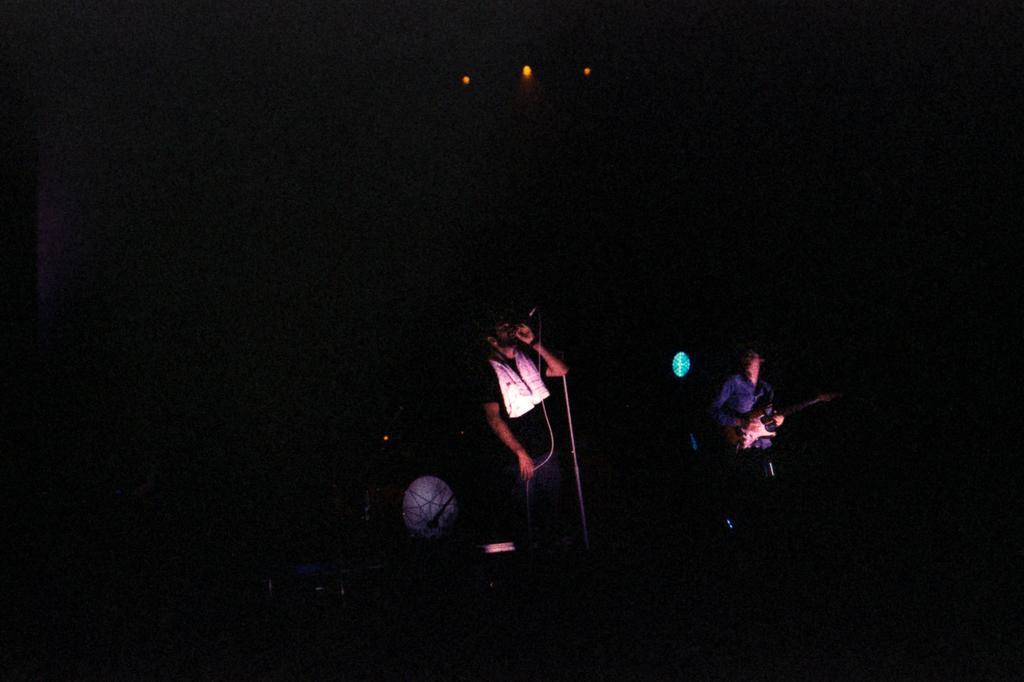Describe this image in one or two sentences. In this image I can see a person standing and holding a microphone and I can see dark background. 